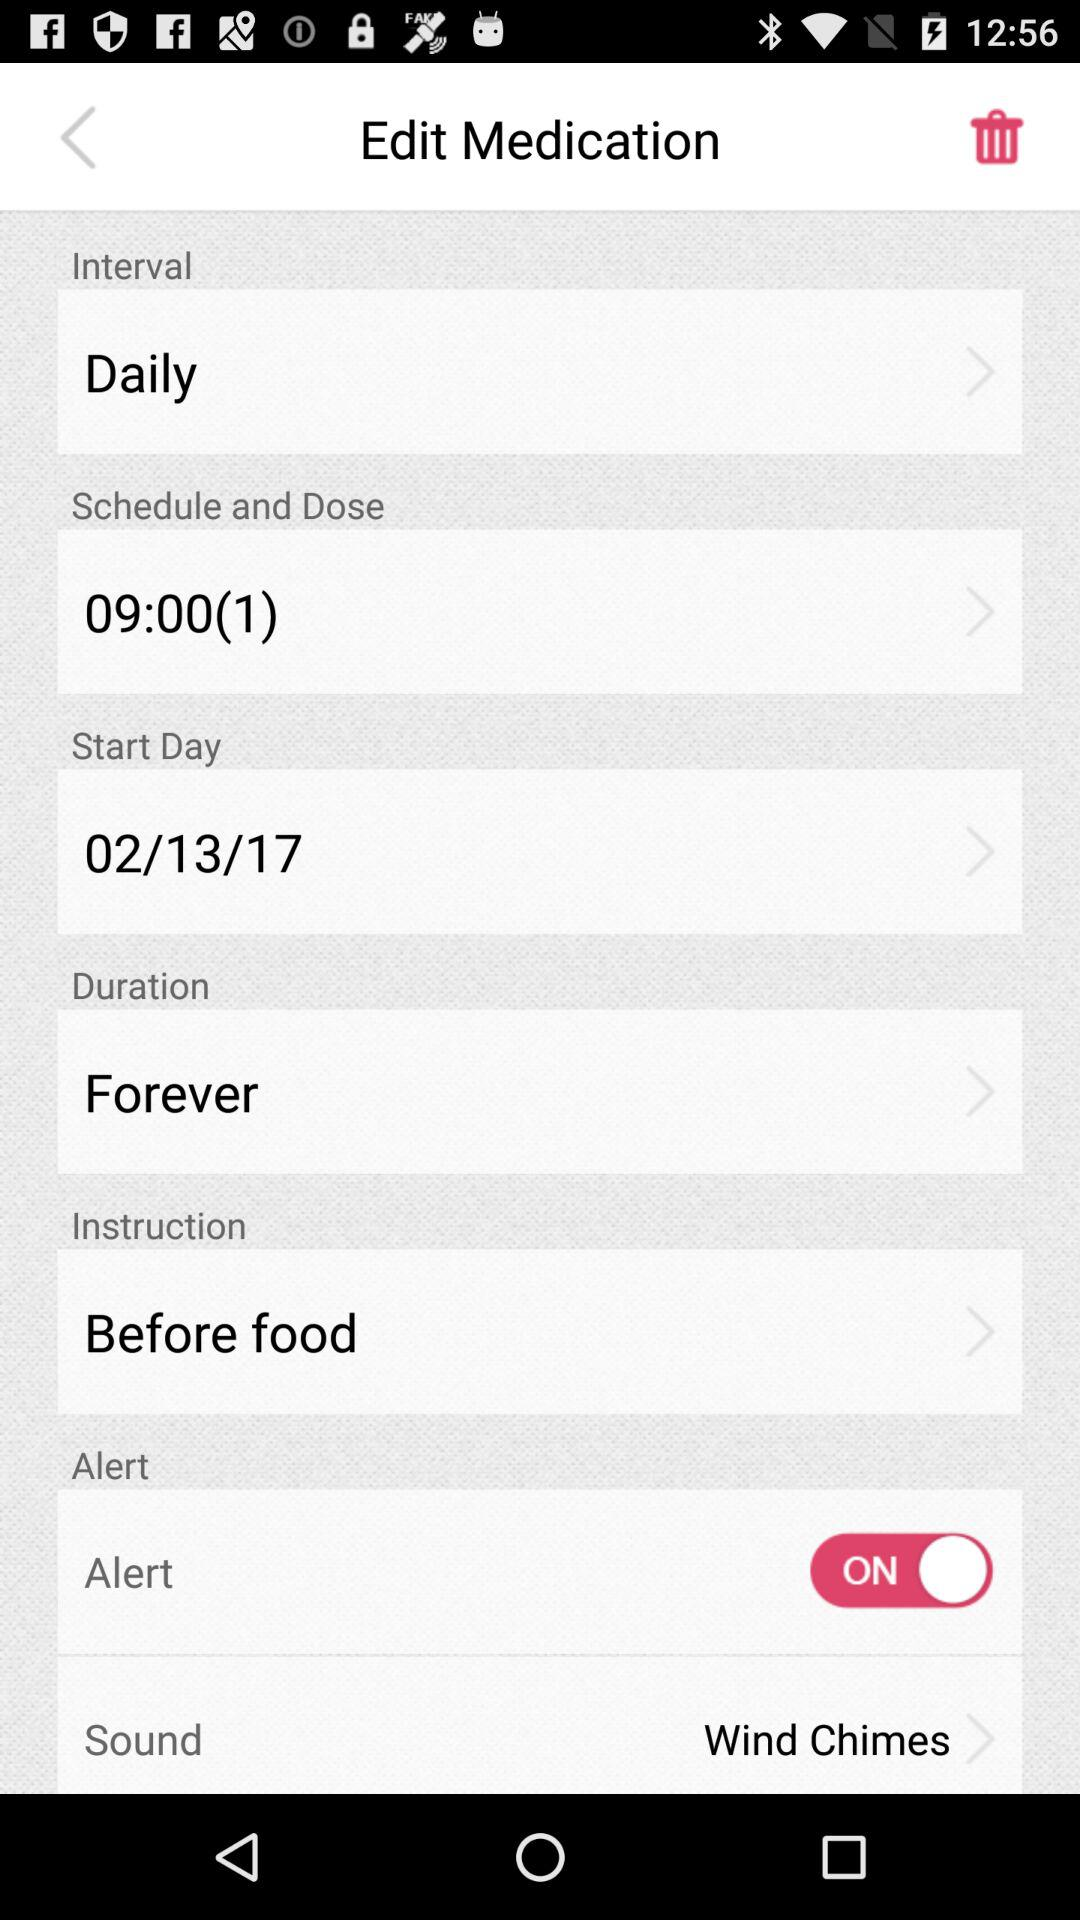What's the scheduled time and dose of medication? The scheduled time is 9:00 and the dose of medication is 1. 